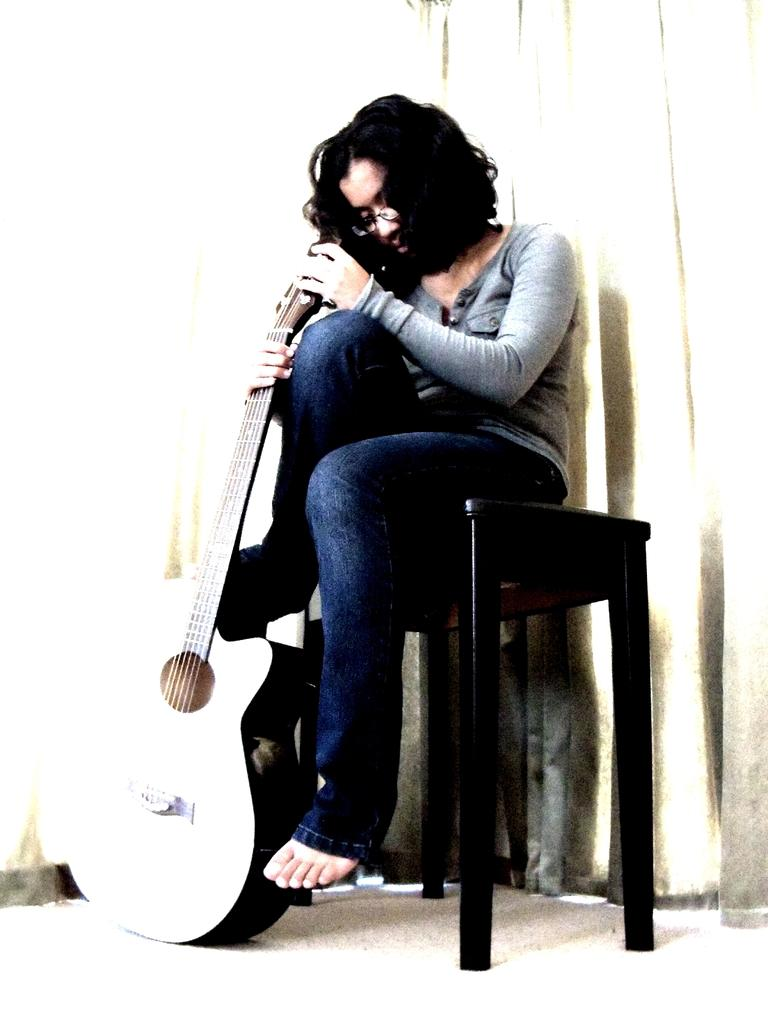Who is the main subject in the image? There is a woman in the image. What is the woman doing in the image? The woman is sitting on a table. What object is the woman holding in the image? The woman is holding a guitar. What type of education can be seen in the image? There is no reference to education in the image; it features a woman sitting on a table and holding a guitar. 